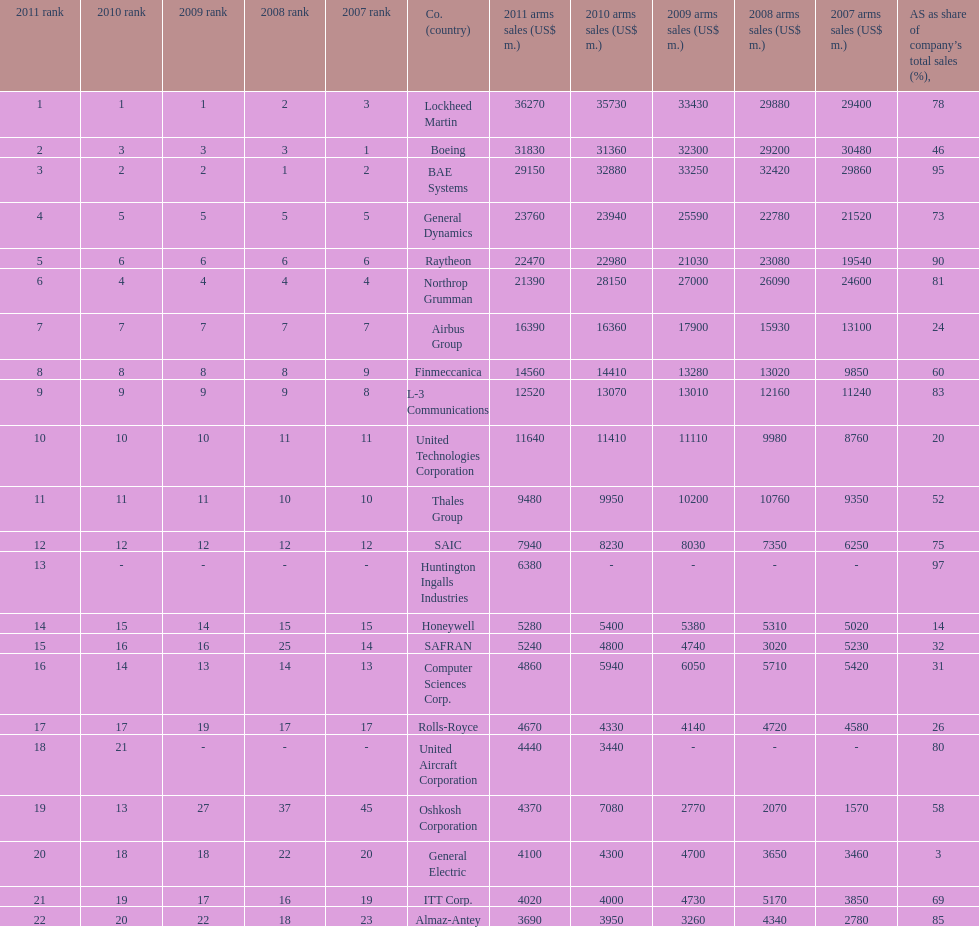How many companies are under the united states? 14. 